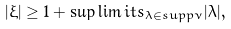<formula> <loc_0><loc_0><loc_500><loc_500>| \xi | \geq 1 + \sup \lim i t s _ { \lambda \in { s u p p } \nu } | \lambda | ,</formula> 